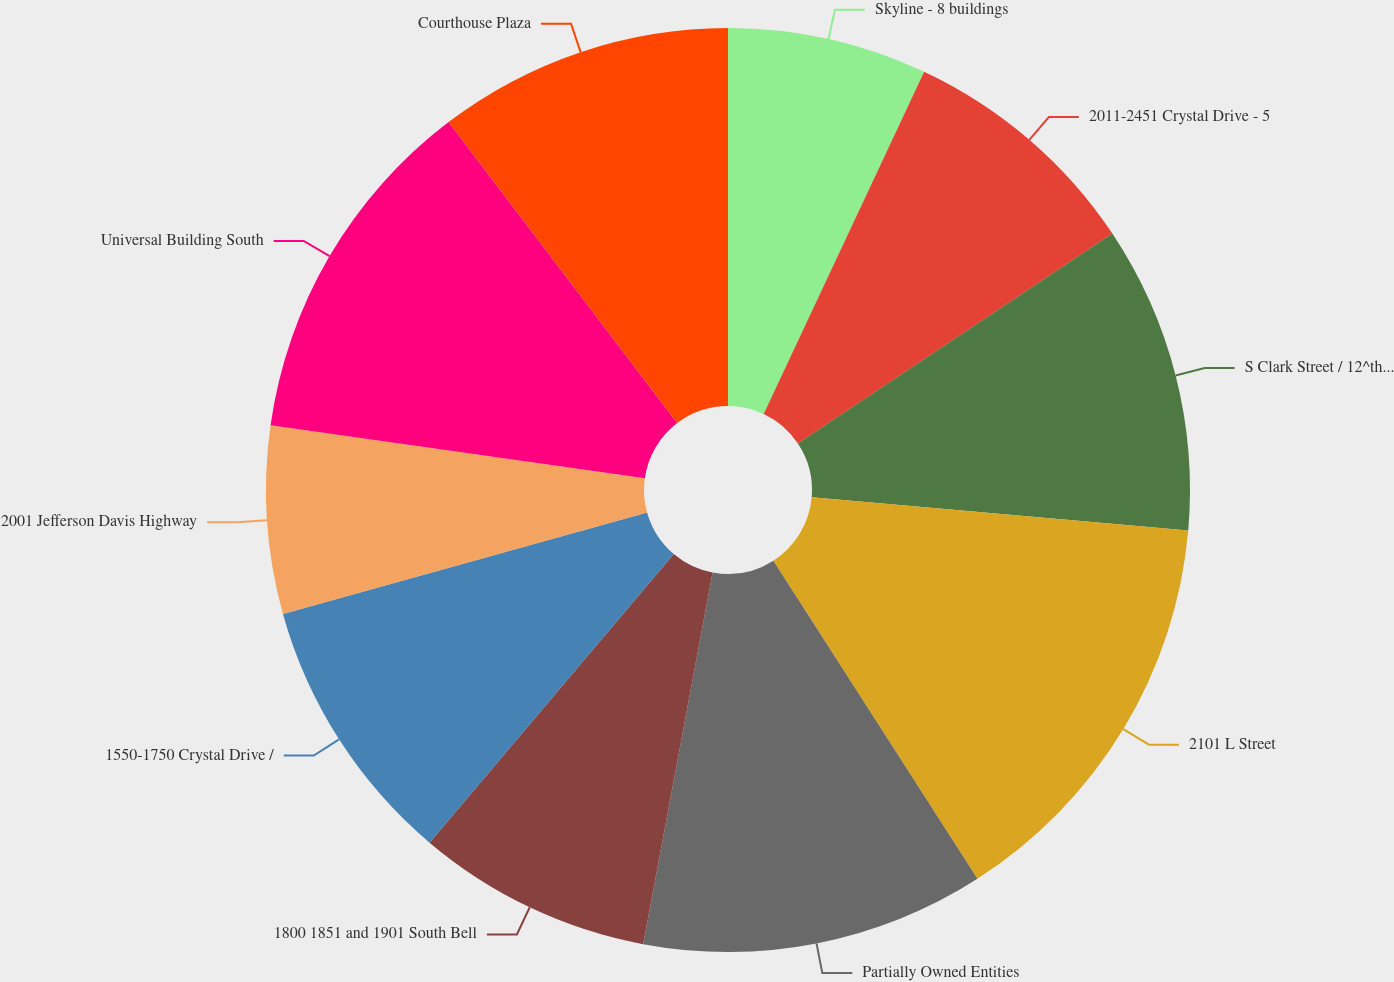<chart> <loc_0><loc_0><loc_500><loc_500><pie_chart><fcel>Skyline - 8 buildings<fcel>2011-2451 Crystal Drive - 5<fcel>S Clark Street / 12^th Street<fcel>2101 L Street<fcel>Partially Owned Entities<fcel>1800 1851 and 1901 South Bell<fcel>1550-1750 Crystal Drive /<fcel>2001 Jefferson Davis Highway<fcel>Universal Building South<fcel>Courthouse Plaza<nl><fcel>6.98%<fcel>8.66%<fcel>10.76%<fcel>14.53%<fcel>12.02%<fcel>8.24%<fcel>9.5%<fcel>6.56%<fcel>12.43%<fcel>10.34%<nl></chart> 